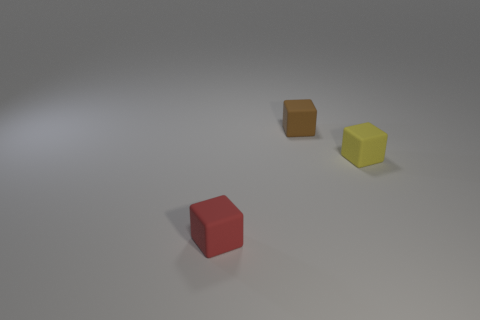Can you describe the lighting and shadows in the scene? The lighting in the scene is diffused and appears to be coming from the upper right, casting soft shadows to the lower left of the cubes, indicating a soft, possibly overcast light source outside of the frame. 